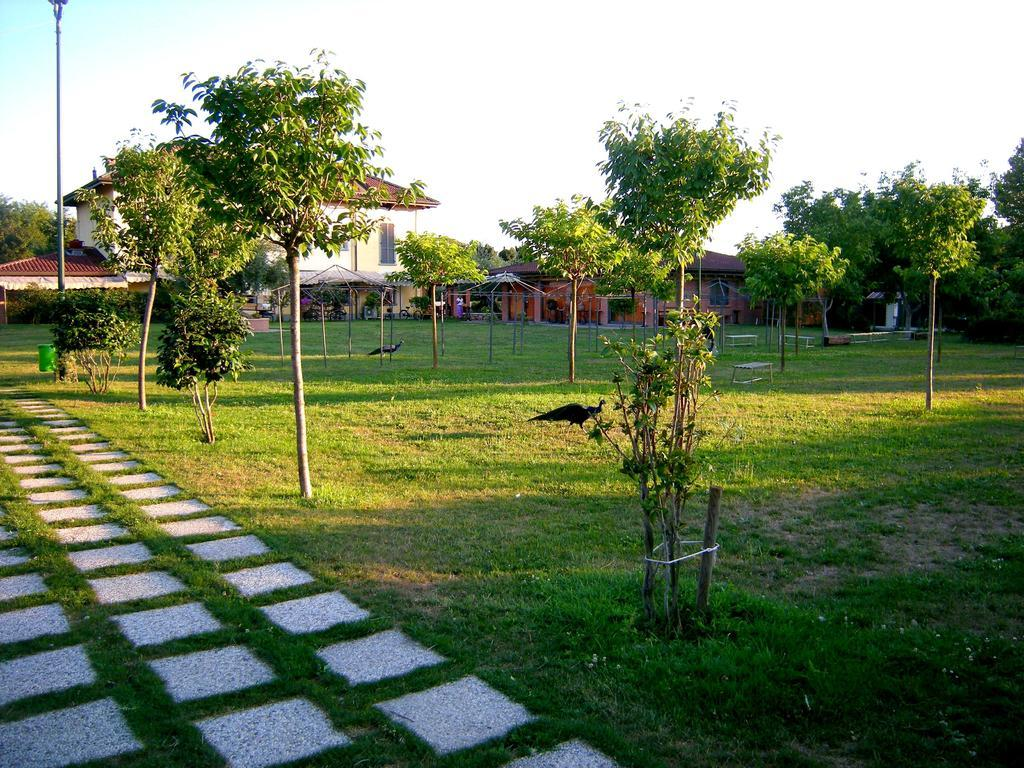What type of surface can be seen in the image? The ground is visible in the image. What type of vegetation is present in the image? There is grass in the image. What other natural elements can be seen in the image? There are trees in the image. What type of animals are present in the image? Birds are present in the image. What type of man-made structures can be seen in the image? There are benches and buildings in the image. What other man-made objects can be seen in the image? A pole is visible in the image. What is visible in the background of the image? The sky is visible in the background of the image. Can you describe the unspecified objects in the image? Unfortunately, the facts provided do not specify the nature of these objects. What type of songs can be heard playing in the background of the image? There is no information about any songs or sounds in the image, so it cannot be determined from the image. What time of day is it in the image, specifically in the afternoon? The facts provided do not specify the time of day, so it cannot be determined from the image. What type of underwear is visible on any of the people in the image? There are no people visible in the image, so it cannot be determined from the image. 